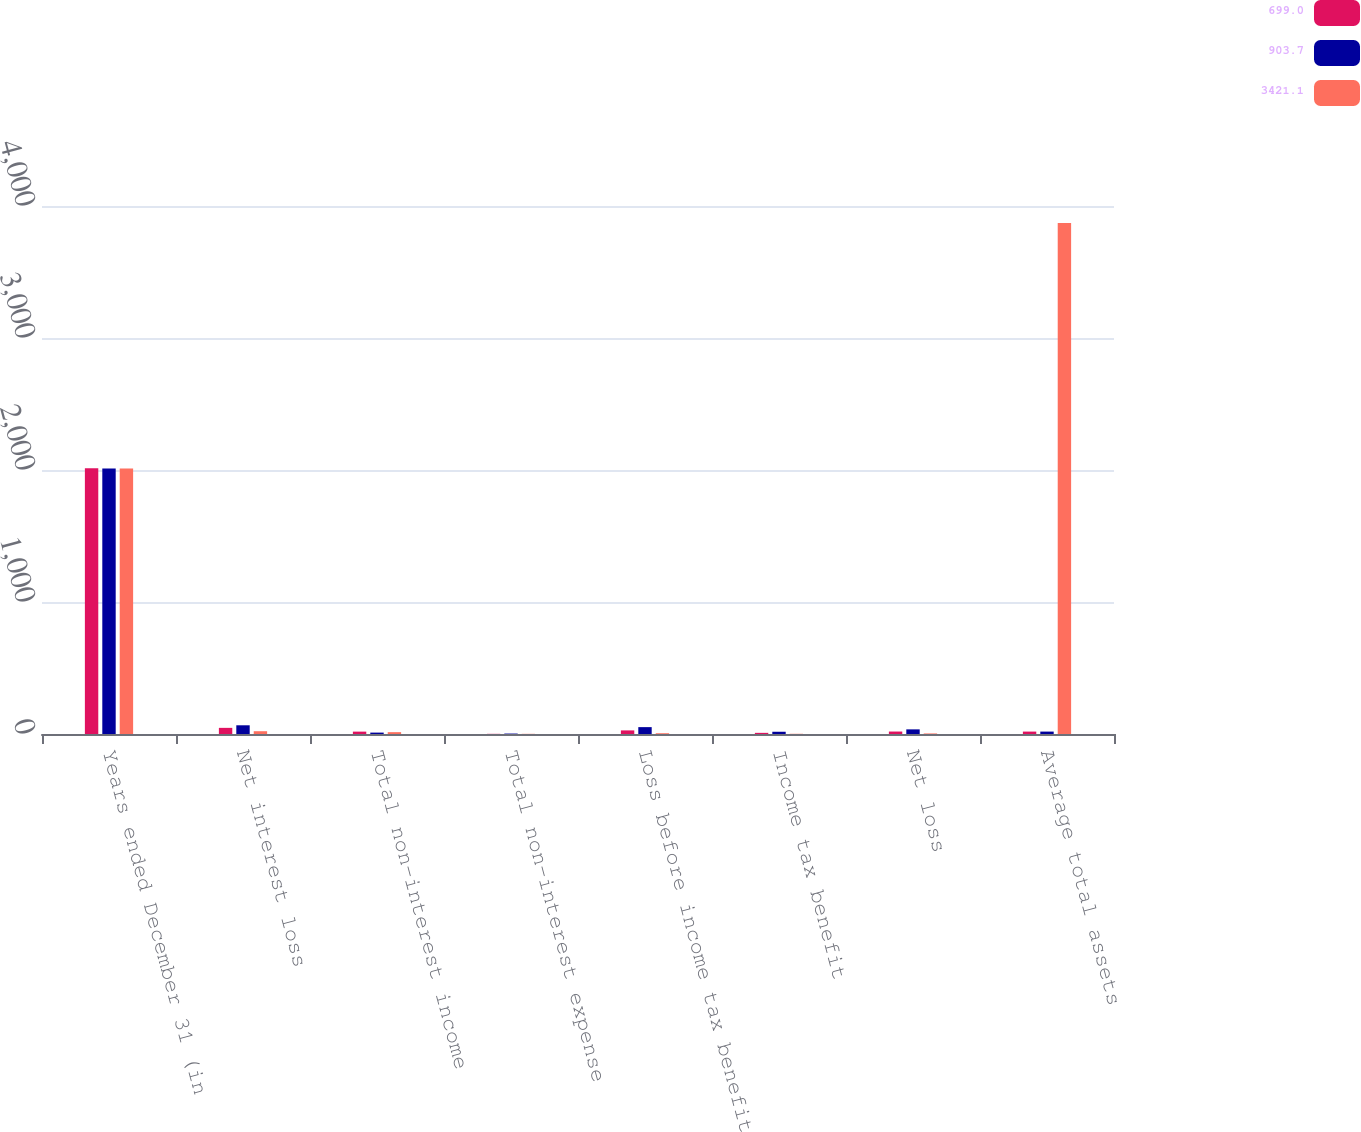Convert chart to OTSL. <chart><loc_0><loc_0><loc_500><loc_500><stacked_bar_chart><ecel><fcel>Years ended December 31 (in<fcel>Net interest loss<fcel>Total non-interest income<fcel>Total non-interest expense<fcel>Loss before income tax benefit<fcel>Income tax benefit<fcel>Net loss<fcel>Average total assets<nl><fcel>699<fcel>2013<fcel>46.5<fcel>18<fcel>1.2<fcel>27.3<fcel>8.7<fcel>18.6<fcel>18.3<nl><fcel>903.7<fcel>2012<fcel>66<fcel>10.6<fcel>3.3<fcel>52.1<fcel>17<fcel>35.1<fcel>18.3<nl><fcel>3421.1<fcel>2011<fcel>21.1<fcel>14<fcel>1.3<fcel>5.8<fcel>1.6<fcel>4.2<fcel>3870.3<nl></chart> 